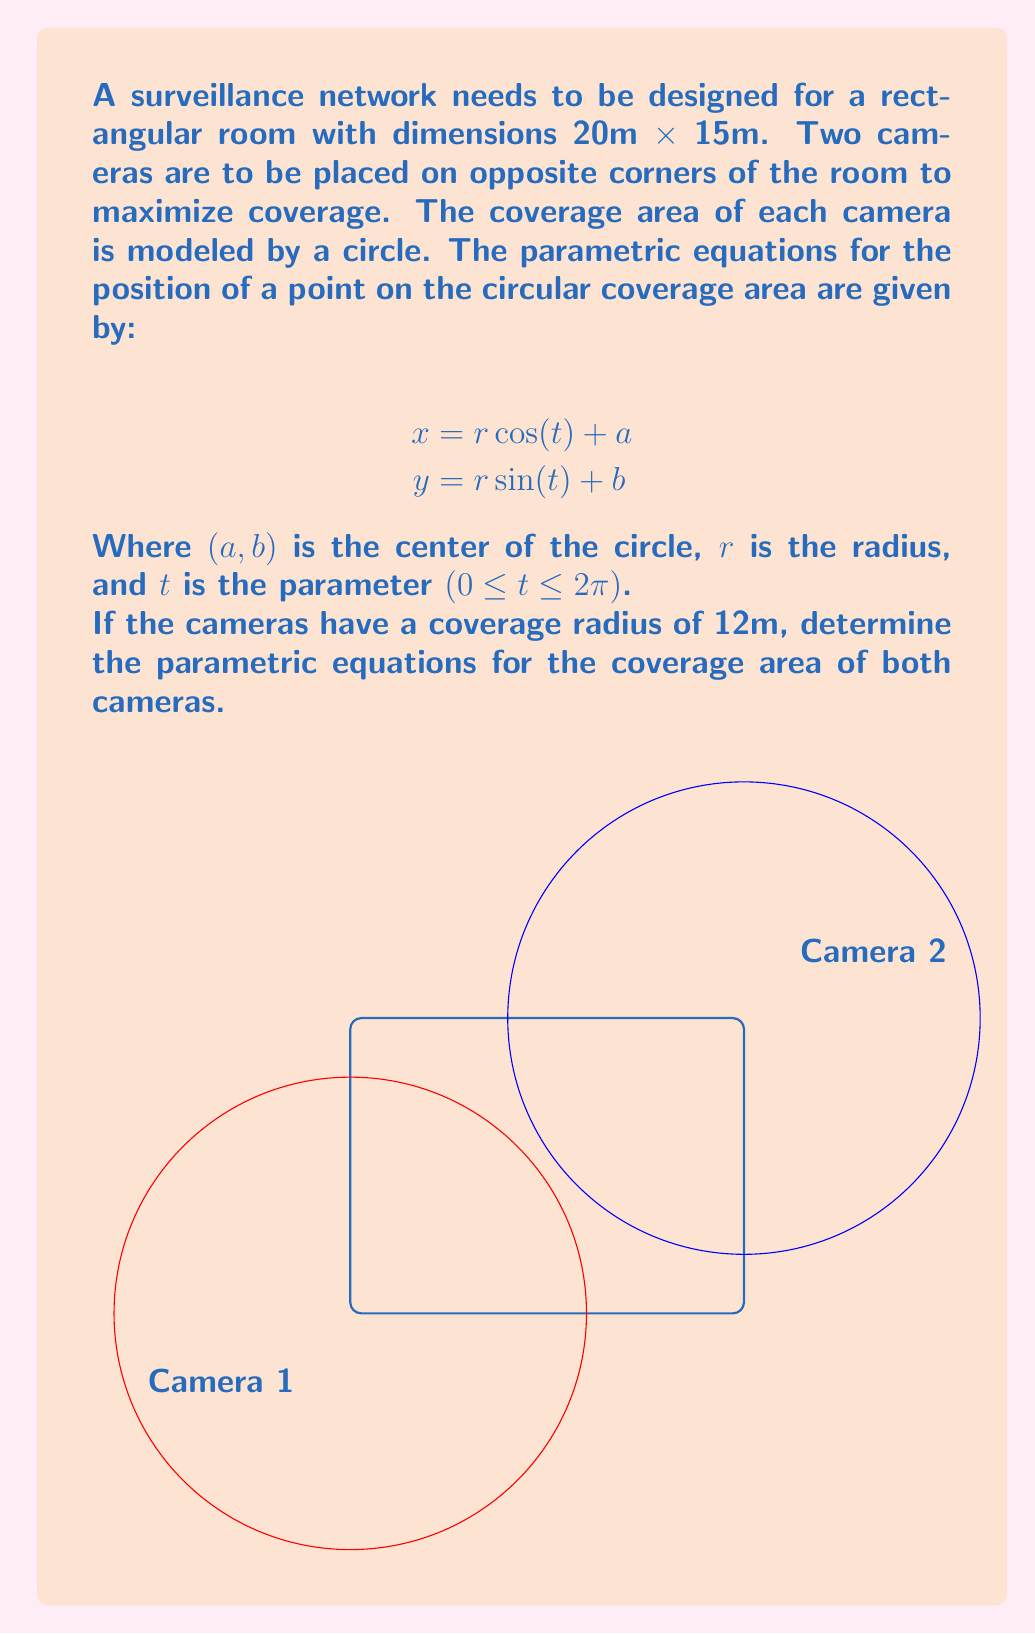Can you solve this math problem? Let's approach this step-by-step:

1) We have two cameras placed at opposite corners of the room. Let's define their positions:
   Camera 1: (0, 0)
   Camera 2: (20, 15)

2) For Camera 1:
   - The center of the circle is at (0, 0), so $a = 0$ and $b = 0$
   - The radius $r = 12$

   Substituting these into the general parametric equations:
   $$x_1 = 12 \cos(t)$$
   $$y_1 = 12 \sin(t)$$

3) For Camera 2:
   - The center of the circle is at (20, 15), so $a = 20$ and $b = 15$
   - The radius $r = 12$

   Substituting these into the general parametric equations:
   $$x_2 = 12 \cos(t) + 20$$
   $$y_2 = 12 \sin(t) + 15$$

4) These equations describe the coverage area for each camera, where $t$ is the parameter $(0 \leq t \leq 2\pi)$.
Answer: Camera 1: $x_1 = 12 \cos(t)$, $y_1 = 12 \sin(t)$
Camera 2: $x_2 = 12 \cos(t) + 20$, $y_2 = 12 \sin(t) + 15$ 